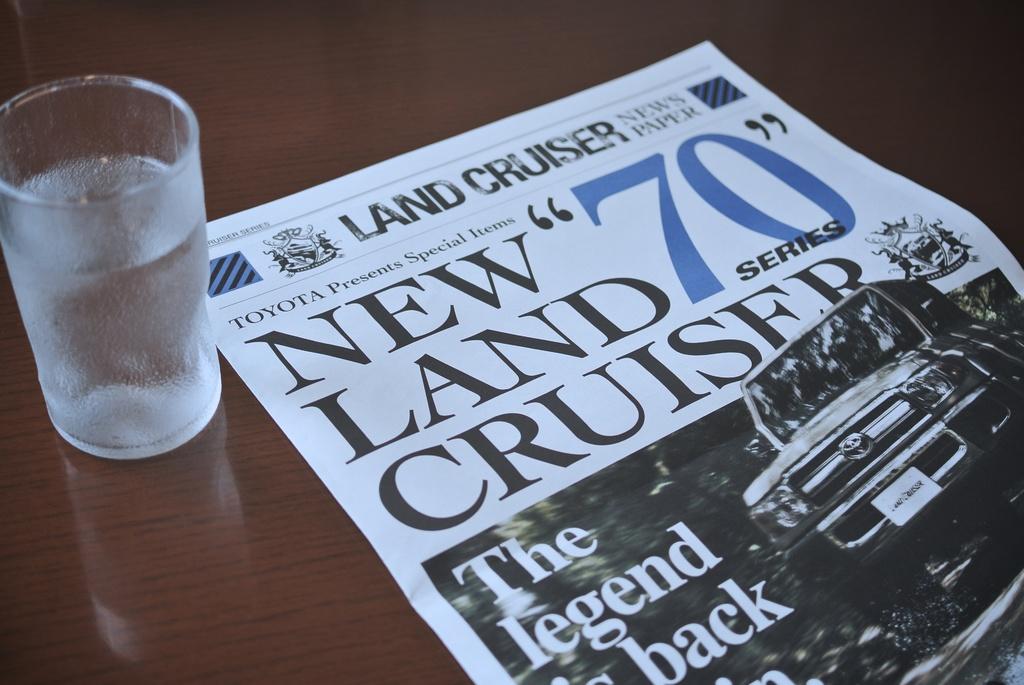What series of vehicle is mentioned on the paper?
Your response must be concise. Land cruiser. What is the big number on the paper/?
Keep it short and to the point. 70. 